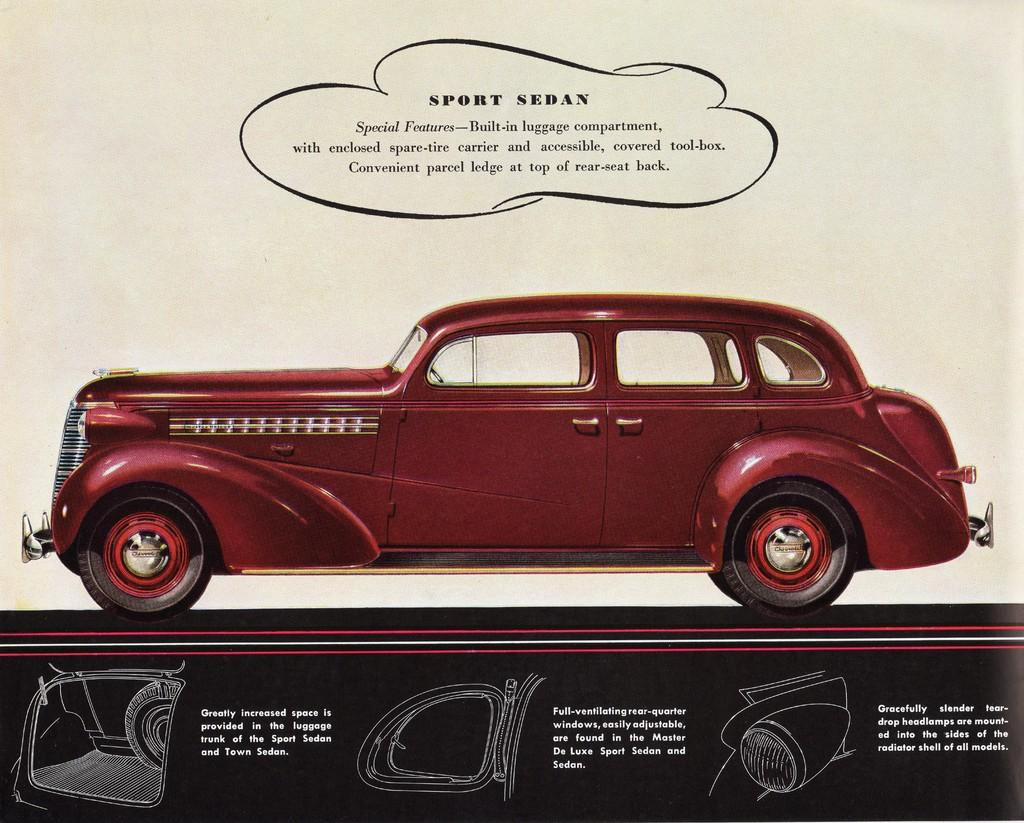What is depicted on the poster in the image? There is a poster with a car in the image. What can be seen at the bottom of the poster? There are parts of the car at the bottom of the poster. What else is featured on the poster besides the car? There is text written on the poster. How many trucks are visible on the poster? There are no trucks visible on the poster; it features a car. What type of haircut is shown on the poster? There is no haircut depicted on the poster; it features a car and text. 